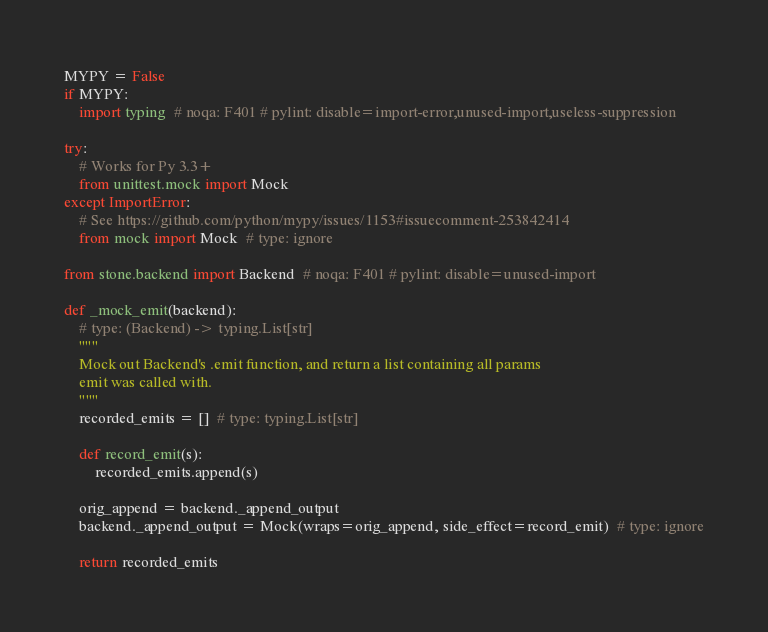Convert code to text. <code><loc_0><loc_0><loc_500><loc_500><_Python_>MYPY = False
if MYPY:
    import typing  # noqa: F401 # pylint: disable=import-error,unused-import,useless-suppression

try:
    # Works for Py 3.3+
    from unittest.mock import Mock
except ImportError:
    # See https://github.com/python/mypy/issues/1153#issuecomment-253842414
    from mock import Mock  # type: ignore

from stone.backend import Backend  # noqa: F401 # pylint: disable=unused-import

def _mock_emit(backend):
    # type: (Backend) -> typing.List[str]
    """
    Mock out Backend's .emit function, and return a list containing all params
    emit was called with.
    """
    recorded_emits = []  # type: typing.List[str]

    def record_emit(s):
        recorded_emits.append(s)

    orig_append = backend._append_output
    backend._append_output = Mock(wraps=orig_append, side_effect=record_emit)  # type: ignore

    return recorded_emits
</code> 